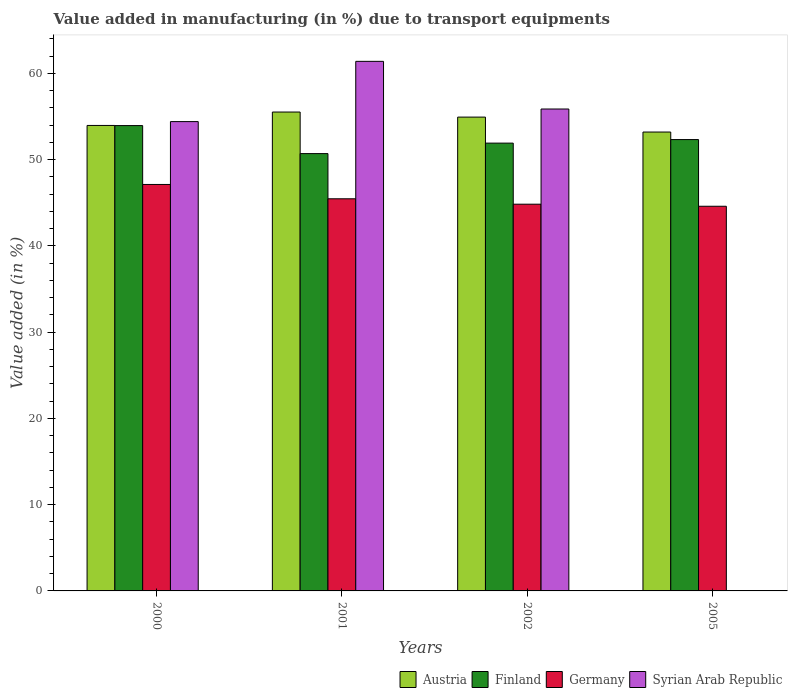How many different coloured bars are there?
Offer a terse response. 4. Are the number of bars on each tick of the X-axis equal?
Provide a short and direct response. No. How many bars are there on the 1st tick from the left?
Provide a short and direct response. 4. How many bars are there on the 1st tick from the right?
Ensure brevity in your answer.  3. What is the percentage of value added in manufacturing due to transport equipments in Syrian Arab Republic in 2002?
Your answer should be compact. 55.87. Across all years, what is the maximum percentage of value added in manufacturing due to transport equipments in Germany?
Your answer should be compact. 47.12. Across all years, what is the minimum percentage of value added in manufacturing due to transport equipments in Germany?
Make the answer very short. 44.6. What is the total percentage of value added in manufacturing due to transport equipments in Austria in the graph?
Your answer should be very brief. 217.62. What is the difference between the percentage of value added in manufacturing due to transport equipments in Syrian Arab Republic in 2001 and that in 2002?
Provide a short and direct response. 5.52. What is the difference between the percentage of value added in manufacturing due to transport equipments in Finland in 2005 and the percentage of value added in manufacturing due to transport equipments in Germany in 2002?
Keep it short and to the point. 7.49. What is the average percentage of value added in manufacturing due to transport equipments in Finland per year?
Ensure brevity in your answer.  52.22. In the year 2002, what is the difference between the percentage of value added in manufacturing due to transport equipments in Austria and percentage of value added in manufacturing due to transport equipments in Finland?
Your response must be concise. 3.02. In how many years, is the percentage of value added in manufacturing due to transport equipments in Finland greater than 40 %?
Keep it short and to the point. 4. What is the ratio of the percentage of value added in manufacturing due to transport equipments in Germany in 2000 to that in 2002?
Your answer should be compact. 1.05. Is the percentage of value added in manufacturing due to transport equipments in Syrian Arab Republic in 2000 less than that in 2002?
Offer a terse response. Yes. Is the difference between the percentage of value added in manufacturing due to transport equipments in Austria in 2002 and 2005 greater than the difference between the percentage of value added in manufacturing due to transport equipments in Finland in 2002 and 2005?
Provide a short and direct response. Yes. What is the difference between the highest and the second highest percentage of value added in manufacturing due to transport equipments in Syrian Arab Republic?
Your response must be concise. 5.52. What is the difference between the highest and the lowest percentage of value added in manufacturing due to transport equipments in Syrian Arab Republic?
Offer a very short reply. 61.4. Is the sum of the percentage of value added in manufacturing due to transport equipments in Austria in 2000 and 2001 greater than the maximum percentage of value added in manufacturing due to transport equipments in Syrian Arab Republic across all years?
Your answer should be very brief. Yes. Is it the case that in every year, the sum of the percentage of value added in manufacturing due to transport equipments in Syrian Arab Republic and percentage of value added in manufacturing due to transport equipments in Austria is greater than the sum of percentage of value added in manufacturing due to transport equipments in Finland and percentage of value added in manufacturing due to transport equipments in Germany?
Make the answer very short. No. How many years are there in the graph?
Ensure brevity in your answer.  4. What is the difference between two consecutive major ticks on the Y-axis?
Give a very brief answer. 10. Are the values on the major ticks of Y-axis written in scientific E-notation?
Offer a terse response. No. Does the graph contain any zero values?
Offer a terse response. Yes. Where does the legend appear in the graph?
Make the answer very short. Bottom right. What is the title of the graph?
Make the answer very short. Value added in manufacturing (in %) due to transport equipments. Does "Mali" appear as one of the legend labels in the graph?
Your response must be concise. No. What is the label or title of the X-axis?
Your answer should be compact. Years. What is the label or title of the Y-axis?
Offer a very short reply. Value added (in %). What is the Value added (in %) in Austria in 2000?
Provide a succinct answer. 53.97. What is the Value added (in %) in Finland in 2000?
Give a very brief answer. 53.95. What is the Value added (in %) of Germany in 2000?
Ensure brevity in your answer.  47.12. What is the Value added (in %) of Syrian Arab Republic in 2000?
Offer a terse response. 54.41. What is the Value added (in %) in Austria in 2001?
Provide a succinct answer. 55.52. What is the Value added (in %) of Finland in 2001?
Provide a succinct answer. 50.7. What is the Value added (in %) of Germany in 2001?
Your response must be concise. 45.46. What is the Value added (in %) of Syrian Arab Republic in 2001?
Give a very brief answer. 61.4. What is the Value added (in %) of Austria in 2002?
Your response must be concise. 54.93. What is the Value added (in %) in Finland in 2002?
Your answer should be compact. 51.92. What is the Value added (in %) of Germany in 2002?
Make the answer very short. 44.84. What is the Value added (in %) in Syrian Arab Republic in 2002?
Ensure brevity in your answer.  55.87. What is the Value added (in %) of Austria in 2005?
Provide a short and direct response. 53.2. What is the Value added (in %) of Finland in 2005?
Offer a terse response. 52.33. What is the Value added (in %) of Germany in 2005?
Offer a very short reply. 44.6. Across all years, what is the maximum Value added (in %) of Austria?
Ensure brevity in your answer.  55.52. Across all years, what is the maximum Value added (in %) in Finland?
Your answer should be very brief. 53.95. Across all years, what is the maximum Value added (in %) of Germany?
Keep it short and to the point. 47.12. Across all years, what is the maximum Value added (in %) in Syrian Arab Republic?
Make the answer very short. 61.4. Across all years, what is the minimum Value added (in %) in Austria?
Your response must be concise. 53.2. Across all years, what is the minimum Value added (in %) in Finland?
Keep it short and to the point. 50.7. Across all years, what is the minimum Value added (in %) in Germany?
Your answer should be very brief. 44.6. Across all years, what is the minimum Value added (in %) in Syrian Arab Republic?
Give a very brief answer. 0. What is the total Value added (in %) of Austria in the graph?
Make the answer very short. 217.62. What is the total Value added (in %) in Finland in the graph?
Your response must be concise. 208.89. What is the total Value added (in %) in Germany in the graph?
Offer a terse response. 182.02. What is the total Value added (in %) of Syrian Arab Republic in the graph?
Ensure brevity in your answer.  171.68. What is the difference between the Value added (in %) in Austria in 2000 and that in 2001?
Offer a very short reply. -1.55. What is the difference between the Value added (in %) in Finland in 2000 and that in 2001?
Your response must be concise. 3.25. What is the difference between the Value added (in %) of Germany in 2000 and that in 2001?
Provide a succinct answer. 1.66. What is the difference between the Value added (in %) in Syrian Arab Republic in 2000 and that in 2001?
Your answer should be very brief. -6.98. What is the difference between the Value added (in %) of Austria in 2000 and that in 2002?
Make the answer very short. -0.97. What is the difference between the Value added (in %) in Finland in 2000 and that in 2002?
Offer a terse response. 2.03. What is the difference between the Value added (in %) of Germany in 2000 and that in 2002?
Offer a terse response. 2.29. What is the difference between the Value added (in %) in Syrian Arab Republic in 2000 and that in 2002?
Offer a very short reply. -1.46. What is the difference between the Value added (in %) in Austria in 2000 and that in 2005?
Ensure brevity in your answer.  0.76. What is the difference between the Value added (in %) in Finland in 2000 and that in 2005?
Your response must be concise. 1.62. What is the difference between the Value added (in %) in Germany in 2000 and that in 2005?
Offer a terse response. 2.53. What is the difference between the Value added (in %) of Austria in 2001 and that in 2002?
Offer a terse response. 0.59. What is the difference between the Value added (in %) of Finland in 2001 and that in 2002?
Keep it short and to the point. -1.21. What is the difference between the Value added (in %) of Germany in 2001 and that in 2002?
Your answer should be compact. 0.63. What is the difference between the Value added (in %) of Syrian Arab Republic in 2001 and that in 2002?
Offer a very short reply. 5.52. What is the difference between the Value added (in %) of Austria in 2001 and that in 2005?
Provide a succinct answer. 2.32. What is the difference between the Value added (in %) of Finland in 2001 and that in 2005?
Your answer should be compact. -1.63. What is the difference between the Value added (in %) of Germany in 2001 and that in 2005?
Your answer should be compact. 0.87. What is the difference between the Value added (in %) in Austria in 2002 and that in 2005?
Offer a terse response. 1.73. What is the difference between the Value added (in %) in Finland in 2002 and that in 2005?
Your response must be concise. -0.41. What is the difference between the Value added (in %) in Germany in 2002 and that in 2005?
Ensure brevity in your answer.  0.24. What is the difference between the Value added (in %) in Austria in 2000 and the Value added (in %) in Finland in 2001?
Give a very brief answer. 3.26. What is the difference between the Value added (in %) of Austria in 2000 and the Value added (in %) of Germany in 2001?
Your response must be concise. 8.5. What is the difference between the Value added (in %) of Austria in 2000 and the Value added (in %) of Syrian Arab Republic in 2001?
Make the answer very short. -7.43. What is the difference between the Value added (in %) of Finland in 2000 and the Value added (in %) of Germany in 2001?
Offer a very short reply. 8.49. What is the difference between the Value added (in %) in Finland in 2000 and the Value added (in %) in Syrian Arab Republic in 2001?
Offer a terse response. -7.45. What is the difference between the Value added (in %) of Germany in 2000 and the Value added (in %) of Syrian Arab Republic in 2001?
Offer a terse response. -14.27. What is the difference between the Value added (in %) in Austria in 2000 and the Value added (in %) in Finland in 2002?
Your answer should be compact. 2.05. What is the difference between the Value added (in %) of Austria in 2000 and the Value added (in %) of Germany in 2002?
Offer a terse response. 9.13. What is the difference between the Value added (in %) of Austria in 2000 and the Value added (in %) of Syrian Arab Republic in 2002?
Offer a very short reply. -1.91. What is the difference between the Value added (in %) in Finland in 2000 and the Value added (in %) in Germany in 2002?
Make the answer very short. 9.11. What is the difference between the Value added (in %) of Finland in 2000 and the Value added (in %) of Syrian Arab Republic in 2002?
Provide a short and direct response. -1.92. What is the difference between the Value added (in %) of Germany in 2000 and the Value added (in %) of Syrian Arab Republic in 2002?
Your answer should be very brief. -8.75. What is the difference between the Value added (in %) of Austria in 2000 and the Value added (in %) of Finland in 2005?
Your response must be concise. 1.64. What is the difference between the Value added (in %) in Austria in 2000 and the Value added (in %) in Germany in 2005?
Make the answer very short. 9.37. What is the difference between the Value added (in %) of Finland in 2000 and the Value added (in %) of Germany in 2005?
Your answer should be compact. 9.35. What is the difference between the Value added (in %) of Austria in 2001 and the Value added (in %) of Finland in 2002?
Make the answer very short. 3.6. What is the difference between the Value added (in %) in Austria in 2001 and the Value added (in %) in Germany in 2002?
Provide a short and direct response. 10.68. What is the difference between the Value added (in %) of Austria in 2001 and the Value added (in %) of Syrian Arab Republic in 2002?
Your answer should be very brief. -0.35. What is the difference between the Value added (in %) in Finland in 2001 and the Value added (in %) in Germany in 2002?
Keep it short and to the point. 5.87. What is the difference between the Value added (in %) of Finland in 2001 and the Value added (in %) of Syrian Arab Republic in 2002?
Offer a terse response. -5.17. What is the difference between the Value added (in %) in Germany in 2001 and the Value added (in %) in Syrian Arab Republic in 2002?
Provide a succinct answer. -10.41. What is the difference between the Value added (in %) in Austria in 2001 and the Value added (in %) in Finland in 2005?
Make the answer very short. 3.19. What is the difference between the Value added (in %) of Austria in 2001 and the Value added (in %) of Germany in 2005?
Offer a very short reply. 10.92. What is the difference between the Value added (in %) in Finland in 2001 and the Value added (in %) in Germany in 2005?
Ensure brevity in your answer.  6.11. What is the difference between the Value added (in %) in Austria in 2002 and the Value added (in %) in Finland in 2005?
Provide a short and direct response. 2.61. What is the difference between the Value added (in %) of Austria in 2002 and the Value added (in %) of Germany in 2005?
Provide a short and direct response. 10.34. What is the difference between the Value added (in %) of Finland in 2002 and the Value added (in %) of Germany in 2005?
Provide a short and direct response. 7.32. What is the average Value added (in %) in Austria per year?
Ensure brevity in your answer.  54.4. What is the average Value added (in %) of Finland per year?
Provide a succinct answer. 52.22. What is the average Value added (in %) of Germany per year?
Give a very brief answer. 45.5. What is the average Value added (in %) in Syrian Arab Republic per year?
Offer a terse response. 42.92. In the year 2000, what is the difference between the Value added (in %) of Austria and Value added (in %) of Finland?
Your answer should be compact. 0.02. In the year 2000, what is the difference between the Value added (in %) in Austria and Value added (in %) in Germany?
Ensure brevity in your answer.  6.84. In the year 2000, what is the difference between the Value added (in %) of Austria and Value added (in %) of Syrian Arab Republic?
Keep it short and to the point. -0.45. In the year 2000, what is the difference between the Value added (in %) of Finland and Value added (in %) of Germany?
Keep it short and to the point. 6.82. In the year 2000, what is the difference between the Value added (in %) of Finland and Value added (in %) of Syrian Arab Republic?
Your answer should be compact. -0.46. In the year 2000, what is the difference between the Value added (in %) in Germany and Value added (in %) in Syrian Arab Republic?
Ensure brevity in your answer.  -7.29. In the year 2001, what is the difference between the Value added (in %) in Austria and Value added (in %) in Finland?
Your answer should be very brief. 4.82. In the year 2001, what is the difference between the Value added (in %) in Austria and Value added (in %) in Germany?
Give a very brief answer. 10.06. In the year 2001, what is the difference between the Value added (in %) of Austria and Value added (in %) of Syrian Arab Republic?
Ensure brevity in your answer.  -5.88. In the year 2001, what is the difference between the Value added (in %) of Finland and Value added (in %) of Germany?
Provide a succinct answer. 5.24. In the year 2001, what is the difference between the Value added (in %) in Finland and Value added (in %) in Syrian Arab Republic?
Your answer should be compact. -10.69. In the year 2001, what is the difference between the Value added (in %) in Germany and Value added (in %) in Syrian Arab Republic?
Offer a terse response. -15.93. In the year 2002, what is the difference between the Value added (in %) of Austria and Value added (in %) of Finland?
Make the answer very short. 3.02. In the year 2002, what is the difference between the Value added (in %) in Austria and Value added (in %) in Germany?
Your response must be concise. 10.1. In the year 2002, what is the difference between the Value added (in %) of Austria and Value added (in %) of Syrian Arab Republic?
Provide a succinct answer. -0.94. In the year 2002, what is the difference between the Value added (in %) in Finland and Value added (in %) in Germany?
Offer a terse response. 7.08. In the year 2002, what is the difference between the Value added (in %) of Finland and Value added (in %) of Syrian Arab Republic?
Your answer should be compact. -3.96. In the year 2002, what is the difference between the Value added (in %) in Germany and Value added (in %) in Syrian Arab Republic?
Your response must be concise. -11.04. In the year 2005, what is the difference between the Value added (in %) of Austria and Value added (in %) of Finland?
Give a very brief answer. 0.87. In the year 2005, what is the difference between the Value added (in %) of Austria and Value added (in %) of Germany?
Your answer should be compact. 8.61. In the year 2005, what is the difference between the Value added (in %) in Finland and Value added (in %) in Germany?
Make the answer very short. 7.73. What is the ratio of the Value added (in %) in Finland in 2000 to that in 2001?
Ensure brevity in your answer.  1.06. What is the ratio of the Value added (in %) in Germany in 2000 to that in 2001?
Give a very brief answer. 1.04. What is the ratio of the Value added (in %) in Syrian Arab Republic in 2000 to that in 2001?
Make the answer very short. 0.89. What is the ratio of the Value added (in %) in Austria in 2000 to that in 2002?
Your answer should be compact. 0.98. What is the ratio of the Value added (in %) of Finland in 2000 to that in 2002?
Your answer should be compact. 1.04. What is the ratio of the Value added (in %) of Germany in 2000 to that in 2002?
Offer a very short reply. 1.05. What is the ratio of the Value added (in %) of Syrian Arab Republic in 2000 to that in 2002?
Offer a terse response. 0.97. What is the ratio of the Value added (in %) in Austria in 2000 to that in 2005?
Ensure brevity in your answer.  1.01. What is the ratio of the Value added (in %) in Finland in 2000 to that in 2005?
Offer a very short reply. 1.03. What is the ratio of the Value added (in %) in Germany in 2000 to that in 2005?
Your answer should be compact. 1.06. What is the ratio of the Value added (in %) of Austria in 2001 to that in 2002?
Offer a very short reply. 1.01. What is the ratio of the Value added (in %) of Finland in 2001 to that in 2002?
Make the answer very short. 0.98. What is the ratio of the Value added (in %) of Syrian Arab Republic in 2001 to that in 2002?
Offer a very short reply. 1.1. What is the ratio of the Value added (in %) of Austria in 2001 to that in 2005?
Provide a short and direct response. 1.04. What is the ratio of the Value added (in %) in Finland in 2001 to that in 2005?
Give a very brief answer. 0.97. What is the ratio of the Value added (in %) in Germany in 2001 to that in 2005?
Keep it short and to the point. 1.02. What is the ratio of the Value added (in %) in Austria in 2002 to that in 2005?
Your answer should be compact. 1.03. What is the ratio of the Value added (in %) in Germany in 2002 to that in 2005?
Offer a terse response. 1.01. What is the difference between the highest and the second highest Value added (in %) of Austria?
Your answer should be compact. 0.59. What is the difference between the highest and the second highest Value added (in %) of Finland?
Give a very brief answer. 1.62. What is the difference between the highest and the second highest Value added (in %) in Germany?
Keep it short and to the point. 1.66. What is the difference between the highest and the second highest Value added (in %) in Syrian Arab Republic?
Offer a very short reply. 5.52. What is the difference between the highest and the lowest Value added (in %) in Austria?
Keep it short and to the point. 2.32. What is the difference between the highest and the lowest Value added (in %) of Finland?
Your answer should be very brief. 3.25. What is the difference between the highest and the lowest Value added (in %) of Germany?
Provide a short and direct response. 2.53. What is the difference between the highest and the lowest Value added (in %) of Syrian Arab Republic?
Offer a terse response. 61.4. 